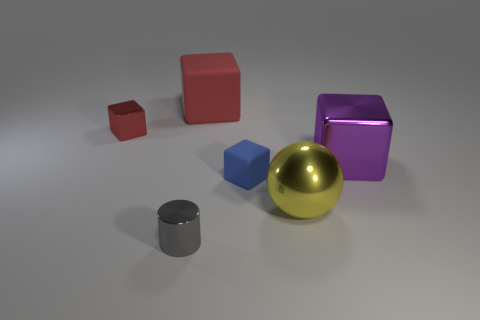What size is the metal object that is in front of the blue cube and to the right of the small gray object?
Keep it short and to the point. Large. There is a tiny object that is both in front of the purple object and behind the cylinder; what color is it?
Provide a succinct answer. Blue. Is the number of metal balls in front of the shiny cylinder less than the number of small metal things in front of the small blue object?
Offer a very short reply. Yes. How many other small metal things have the same shape as the yellow shiny thing?
Provide a short and direct response. 0. What size is the yellow object that is the same material as the gray cylinder?
Your answer should be compact. Large. The large block that is in front of the metallic block that is behind the purple metallic thing is what color?
Give a very brief answer. Purple. There is a tiny gray shiny object; is it the same shape as the big metal object behind the small blue rubber object?
Provide a succinct answer. No. Are there an equal number of small green spheres and tiny gray cylinders?
Ensure brevity in your answer.  No. What number of cyan things are the same size as the purple block?
Your answer should be compact. 0. There is another tiny object that is the same shape as the red metal thing; what is it made of?
Your answer should be very brief. Rubber. 